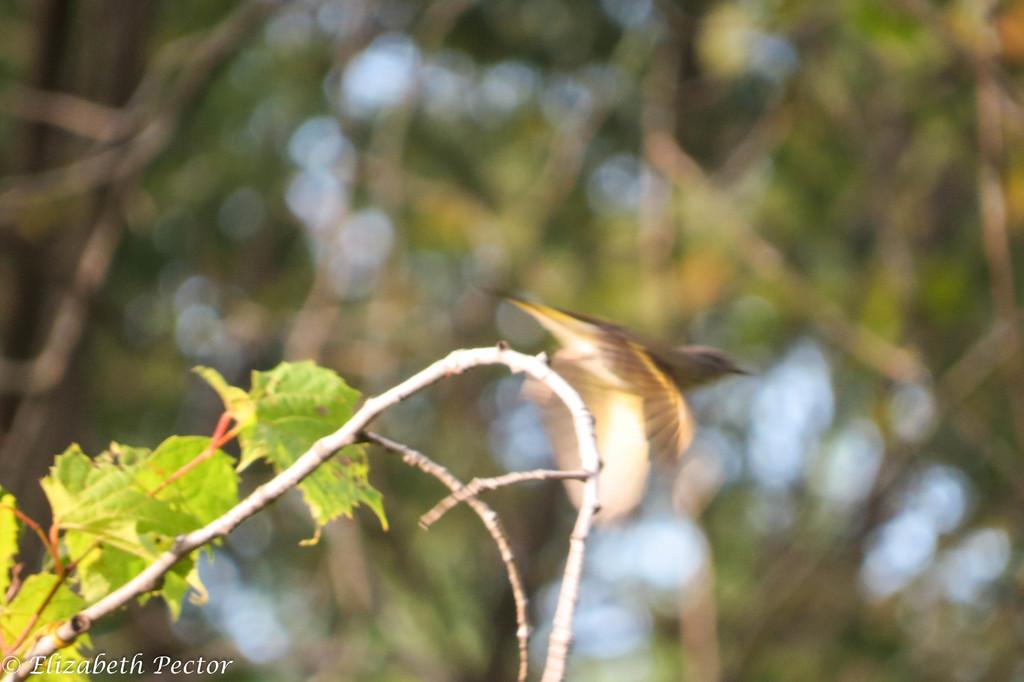What is the main subject in the front of the image? There is a plant in the front of the image. Can you describe the describe the background of the image? The background of the image is blurry. What type of idea can be seen hopping around in the image? There is no idea or rabbit present in the image; it features a plant in the front and a blurry background. What kind of twig is visible in the image? There is no twig mentioned in the provided facts, so it cannot be determined if a twig is present in the image. 